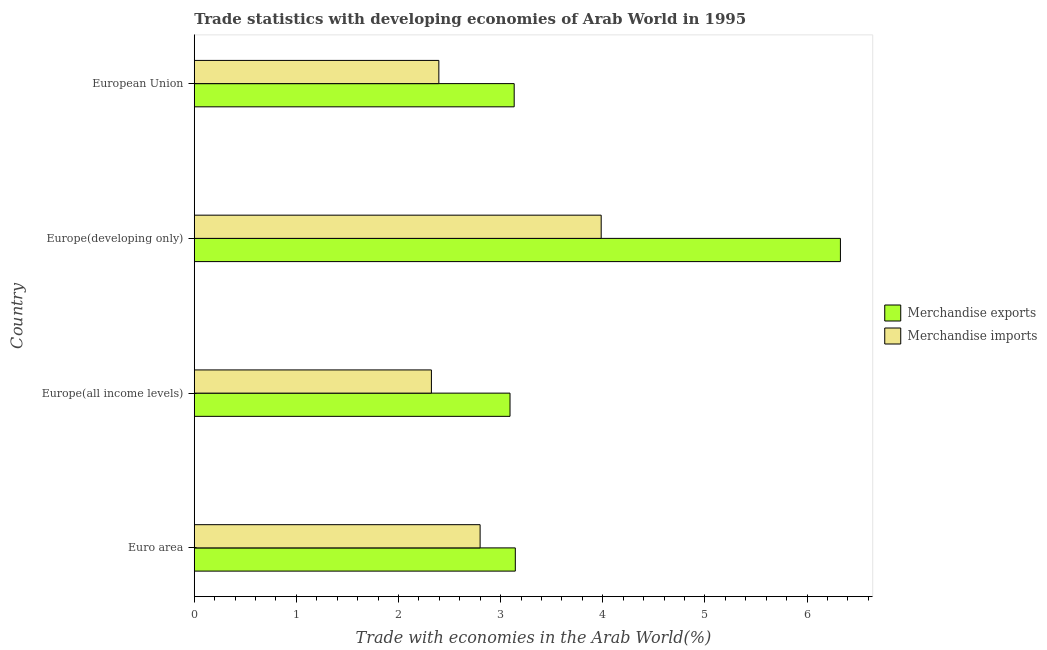Are the number of bars per tick equal to the number of legend labels?
Provide a succinct answer. Yes. What is the label of the 2nd group of bars from the top?
Provide a succinct answer. Europe(developing only). What is the merchandise exports in Europe(developing only)?
Keep it short and to the point. 6.33. Across all countries, what is the maximum merchandise imports?
Ensure brevity in your answer.  3.98. Across all countries, what is the minimum merchandise imports?
Your response must be concise. 2.32. In which country was the merchandise imports maximum?
Offer a terse response. Europe(developing only). In which country was the merchandise imports minimum?
Your answer should be very brief. Europe(all income levels). What is the total merchandise exports in the graph?
Your answer should be very brief. 15.69. What is the difference between the merchandise exports in Euro area and that in Europe(all income levels)?
Offer a terse response. 0.05. What is the difference between the merchandise exports in Europe(developing only) and the merchandise imports in European Union?
Offer a very short reply. 3.93. What is the average merchandise exports per country?
Provide a succinct answer. 3.92. What is the difference between the merchandise exports and merchandise imports in European Union?
Your answer should be compact. 0.74. What is the ratio of the merchandise exports in Euro area to that in European Union?
Your answer should be compact. 1. Is the merchandise exports in Europe(developing only) less than that in European Union?
Offer a very short reply. No. What is the difference between the highest and the second highest merchandise imports?
Provide a succinct answer. 1.19. What is the difference between the highest and the lowest merchandise exports?
Give a very brief answer. 3.23. Is the sum of the merchandise imports in Europe(developing only) and European Union greater than the maximum merchandise exports across all countries?
Offer a terse response. Yes. What does the 2nd bar from the top in European Union represents?
Make the answer very short. Merchandise exports. What does the 2nd bar from the bottom in Europe(developing only) represents?
Ensure brevity in your answer.  Merchandise imports. Are all the bars in the graph horizontal?
Provide a short and direct response. Yes. How many countries are there in the graph?
Give a very brief answer. 4. What is the difference between two consecutive major ticks on the X-axis?
Offer a terse response. 1. Are the values on the major ticks of X-axis written in scientific E-notation?
Provide a short and direct response. No. Does the graph contain any zero values?
Give a very brief answer. No. Where does the legend appear in the graph?
Make the answer very short. Center right. How many legend labels are there?
Keep it short and to the point. 2. What is the title of the graph?
Your answer should be very brief. Trade statistics with developing economies of Arab World in 1995. Does "Travel services" appear as one of the legend labels in the graph?
Keep it short and to the point. No. What is the label or title of the X-axis?
Ensure brevity in your answer.  Trade with economies in the Arab World(%). What is the label or title of the Y-axis?
Give a very brief answer. Country. What is the Trade with economies in the Arab World(%) of Merchandise exports in Euro area?
Provide a succinct answer. 3.14. What is the Trade with economies in the Arab World(%) in Merchandise imports in Euro area?
Your answer should be very brief. 2.8. What is the Trade with economies in the Arab World(%) in Merchandise exports in Europe(all income levels)?
Offer a terse response. 3.09. What is the Trade with economies in the Arab World(%) in Merchandise imports in Europe(all income levels)?
Offer a terse response. 2.32. What is the Trade with economies in the Arab World(%) of Merchandise exports in Europe(developing only)?
Make the answer very short. 6.33. What is the Trade with economies in the Arab World(%) of Merchandise imports in Europe(developing only)?
Your response must be concise. 3.98. What is the Trade with economies in the Arab World(%) of Merchandise exports in European Union?
Keep it short and to the point. 3.13. What is the Trade with economies in the Arab World(%) of Merchandise imports in European Union?
Provide a succinct answer. 2.39. Across all countries, what is the maximum Trade with economies in the Arab World(%) in Merchandise exports?
Give a very brief answer. 6.33. Across all countries, what is the maximum Trade with economies in the Arab World(%) in Merchandise imports?
Offer a very short reply. 3.98. Across all countries, what is the minimum Trade with economies in the Arab World(%) in Merchandise exports?
Make the answer very short. 3.09. Across all countries, what is the minimum Trade with economies in the Arab World(%) of Merchandise imports?
Provide a short and direct response. 2.32. What is the total Trade with economies in the Arab World(%) of Merchandise exports in the graph?
Keep it short and to the point. 15.69. What is the total Trade with economies in the Arab World(%) in Merchandise imports in the graph?
Offer a terse response. 11.5. What is the difference between the Trade with economies in the Arab World(%) of Merchandise exports in Euro area and that in Europe(all income levels)?
Your answer should be very brief. 0.05. What is the difference between the Trade with economies in the Arab World(%) in Merchandise imports in Euro area and that in Europe(all income levels)?
Offer a terse response. 0.48. What is the difference between the Trade with economies in the Arab World(%) in Merchandise exports in Euro area and that in Europe(developing only)?
Provide a succinct answer. -3.18. What is the difference between the Trade with economies in the Arab World(%) in Merchandise imports in Euro area and that in Europe(developing only)?
Provide a succinct answer. -1.19. What is the difference between the Trade with economies in the Arab World(%) in Merchandise exports in Euro area and that in European Union?
Offer a very short reply. 0.01. What is the difference between the Trade with economies in the Arab World(%) of Merchandise imports in Euro area and that in European Union?
Offer a terse response. 0.4. What is the difference between the Trade with economies in the Arab World(%) in Merchandise exports in Europe(all income levels) and that in Europe(developing only)?
Give a very brief answer. -3.23. What is the difference between the Trade with economies in the Arab World(%) of Merchandise imports in Europe(all income levels) and that in Europe(developing only)?
Your answer should be compact. -1.66. What is the difference between the Trade with economies in the Arab World(%) of Merchandise exports in Europe(all income levels) and that in European Union?
Your answer should be compact. -0.04. What is the difference between the Trade with economies in the Arab World(%) in Merchandise imports in Europe(all income levels) and that in European Union?
Make the answer very short. -0.07. What is the difference between the Trade with economies in the Arab World(%) of Merchandise exports in Europe(developing only) and that in European Union?
Your answer should be compact. 3.19. What is the difference between the Trade with economies in the Arab World(%) of Merchandise imports in Europe(developing only) and that in European Union?
Make the answer very short. 1.59. What is the difference between the Trade with economies in the Arab World(%) in Merchandise exports in Euro area and the Trade with economies in the Arab World(%) in Merchandise imports in Europe(all income levels)?
Provide a short and direct response. 0.82. What is the difference between the Trade with economies in the Arab World(%) in Merchandise exports in Euro area and the Trade with economies in the Arab World(%) in Merchandise imports in Europe(developing only)?
Your answer should be compact. -0.84. What is the difference between the Trade with economies in the Arab World(%) of Merchandise exports in Euro area and the Trade with economies in the Arab World(%) of Merchandise imports in European Union?
Your answer should be compact. 0.75. What is the difference between the Trade with economies in the Arab World(%) of Merchandise exports in Europe(all income levels) and the Trade with economies in the Arab World(%) of Merchandise imports in Europe(developing only)?
Offer a terse response. -0.89. What is the difference between the Trade with economies in the Arab World(%) in Merchandise exports in Europe(all income levels) and the Trade with economies in the Arab World(%) in Merchandise imports in European Union?
Your answer should be very brief. 0.7. What is the difference between the Trade with economies in the Arab World(%) in Merchandise exports in Europe(developing only) and the Trade with economies in the Arab World(%) in Merchandise imports in European Union?
Give a very brief answer. 3.93. What is the average Trade with economies in the Arab World(%) in Merchandise exports per country?
Offer a terse response. 3.92. What is the average Trade with economies in the Arab World(%) in Merchandise imports per country?
Your response must be concise. 2.87. What is the difference between the Trade with economies in the Arab World(%) in Merchandise exports and Trade with economies in the Arab World(%) in Merchandise imports in Euro area?
Make the answer very short. 0.34. What is the difference between the Trade with economies in the Arab World(%) of Merchandise exports and Trade with economies in the Arab World(%) of Merchandise imports in Europe(all income levels)?
Your answer should be very brief. 0.77. What is the difference between the Trade with economies in the Arab World(%) in Merchandise exports and Trade with economies in the Arab World(%) in Merchandise imports in Europe(developing only)?
Make the answer very short. 2.34. What is the difference between the Trade with economies in the Arab World(%) of Merchandise exports and Trade with economies in the Arab World(%) of Merchandise imports in European Union?
Offer a terse response. 0.74. What is the ratio of the Trade with economies in the Arab World(%) in Merchandise exports in Euro area to that in Europe(all income levels)?
Make the answer very short. 1.02. What is the ratio of the Trade with economies in the Arab World(%) of Merchandise imports in Euro area to that in Europe(all income levels)?
Your response must be concise. 1.21. What is the ratio of the Trade with economies in the Arab World(%) of Merchandise exports in Euro area to that in Europe(developing only)?
Provide a short and direct response. 0.5. What is the ratio of the Trade with economies in the Arab World(%) of Merchandise imports in Euro area to that in Europe(developing only)?
Provide a short and direct response. 0.7. What is the ratio of the Trade with economies in the Arab World(%) in Merchandise imports in Euro area to that in European Union?
Your answer should be compact. 1.17. What is the ratio of the Trade with economies in the Arab World(%) of Merchandise exports in Europe(all income levels) to that in Europe(developing only)?
Make the answer very short. 0.49. What is the ratio of the Trade with economies in the Arab World(%) of Merchandise imports in Europe(all income levels) to that in Europe(developing only)?
Your response must be concise. 0.58. What is the ratio of the Trade with economies in the Arab World(%) of Merchandise exports in Europe(all income levels) to that in European Union?
Ensure brevity in your answer.  0.99. What is the ratio of the Trade with economies in the Arab World(%) of Merchandise imports in Europe(all income levels) to that in European Union?
Offer a very short reply. 0.97. What is the ratio of the Trade with economies in the Arab World(%) of Merchandise exports in Europe(developing only) to that in European Union?
Offer a terse response. 2.02. What is the ratio of the Trade with economies in the Arab World(%) in Merchandise imports in Europe(developing only) to that in European Union?
Make the answer very short. 1.66. What is the difference between the highest and the second highest Trade with economies in the Arab World(%) in Merchandise exports?
Offer a terse response. 3.18. What is the difference between the highest and the second highest Trade with economies in the Arab World(%) in Merchandise imports?
Offer a very short reply. 1.19. What is the difference between the highest and the lowest Trade with economies in the Arab World(%) of Merchandise exports?
Keep it short and to the point. 3.23. What is the difference between the highest and the lowest Trade with economies in the Arab World(%) of Merchandise imports?
Your answer should be compact. 1.66. 